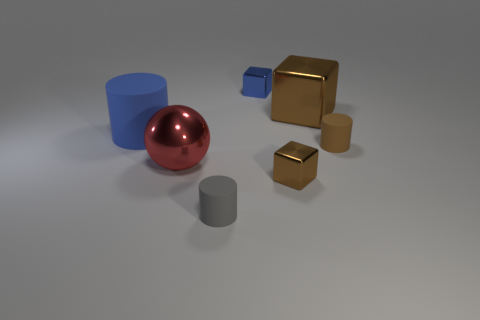There is a blue object that is behind the matte object to the left of the gray object; what is it made of?
Keep it short and to the point. Metal. How many cyan metallic things have the same shape as the tiny blue metal object?
Keep it short and to the point. 0. What shape is the gray object?
Provide a succinct answer. Cylinder. Is the number of spheres less than the number of brown cubes?
Offer a very short reply. Yes. Are there any other things that are the same size as the red sphere?
Ensure brevity in your answer.  Yes. There is another tiny object that is the same shape as the small blue shiny object; what material is it?
Your answer should be compact. Metal. Are there more matte objects than large metallic balls?
Provide a succinct answer. Yes. How many other objects are the same color as the metal ball?
Keep it short and to the point. 0. Are the small brown cube and the tiny brown thing that is behind the large red shiny sphere made of the same material?
Make the answer very short. No. How many big red metal balls are in front of the cylinder that is in front of the tiny matte cylinder that is to the right of the small brown block?
Provide a short and direct response. 0. 